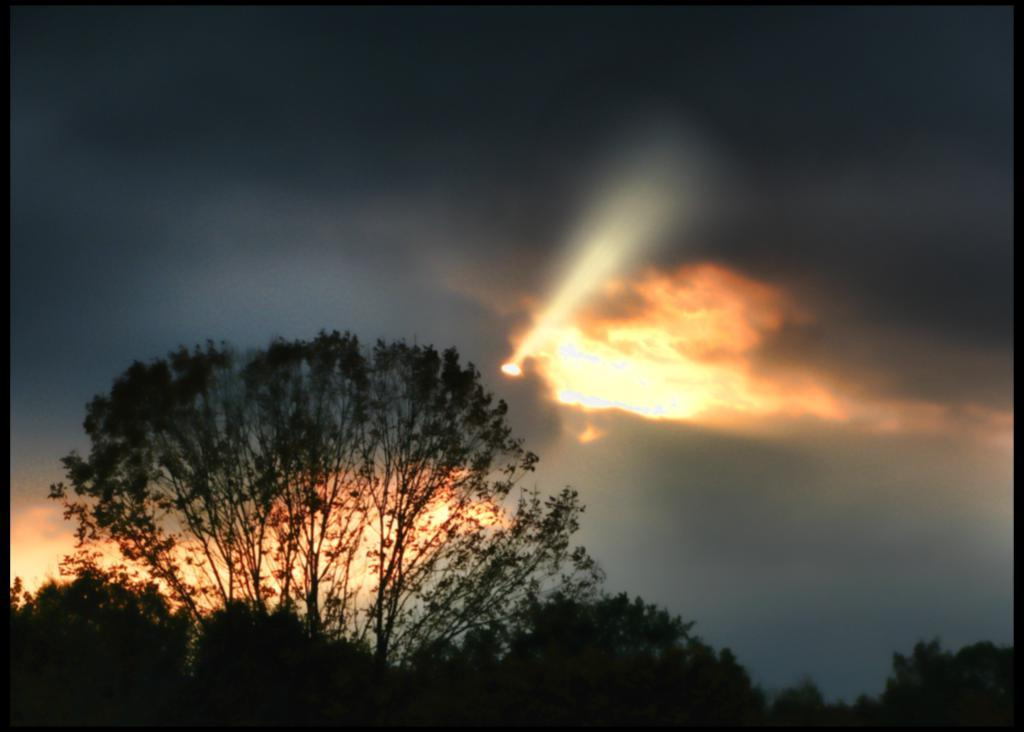What type of vegetation can be seen in the image? There are trees in the image. What part of the natural environment is visible in the image? The sky is visible in the image. What can be observed in the sky? Clouds are present in the sky. What is the source of light in the image? Sunlight is visible in the image. What type of oatmeal is being eaten by the trees in the image? There is no oatmeal present in the image, as it features trees and a sky with clouds. How does the behavior of the clouds in the image affect the trees? The image does not depict any behavior of the clouds or their effect on the trees; it simply shows trees and clouds in the sky. 